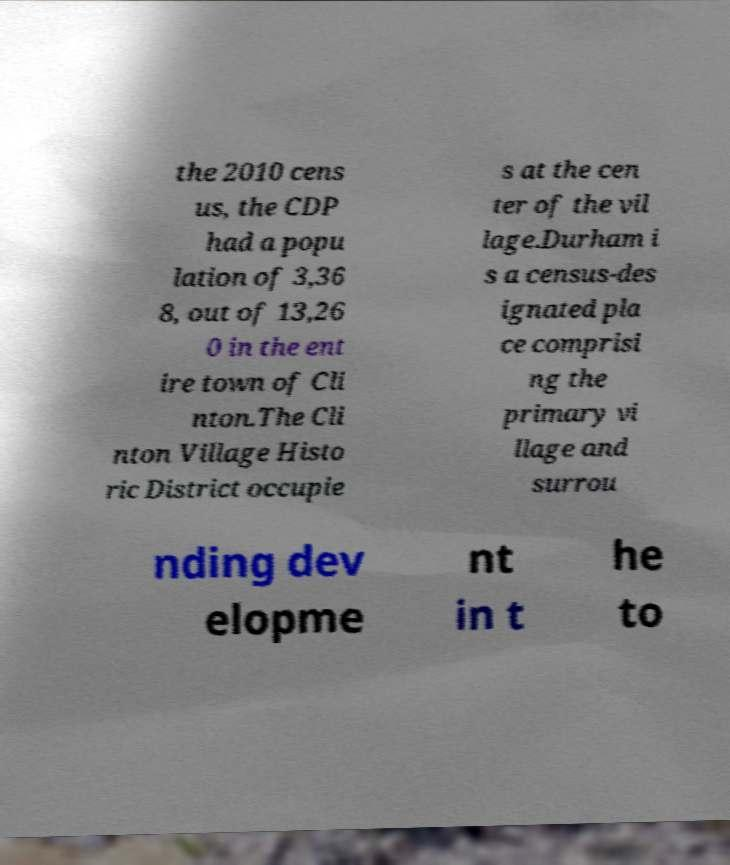There's text embedded in this image that I need extracted. Can you transcribe it verbatim? the 2010 cens us, the CDP had a popu lation of 3,36 8, out of 13,26 0 in the ent ire town of Cli nton.The Cli nton Village Histo ric District occupie s at the cen ter of the vil lage.Durham i s a census-des ignated pla ce comprisi ng the primary vi llage and surrou nding dev elopme nt in t he to 